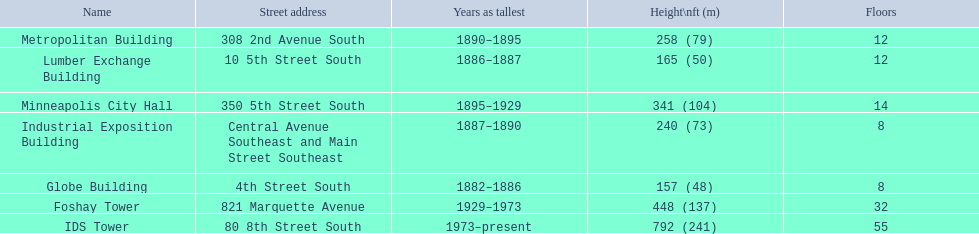What years was 240 ft considered tall? 1887–1890. What building held this record? Industrial Exposition Building. 